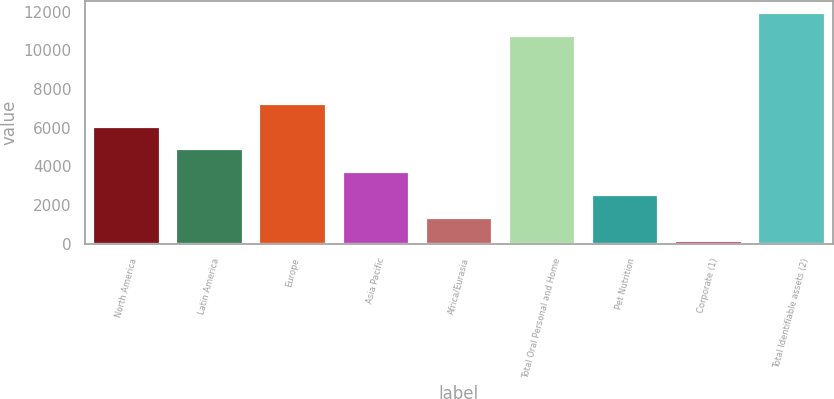Convert chart. <chart><loc_0><loc_0><loc_500><loc_500><bar_chart><fcel>North America<fcel>Latin America<fcel>Europe<fcel>Asia Pacific<fcel>Africa/Eurasia<fcel>Total Oral Personal and Home<fcel>Pet Nutrition<fcel>Corporate (1)<fcel>Total Identifiable assets (2)<nl><fcel>6056.5<fcel>4880.8<fcel>7232.2<fcel>3705.1<fcel>1353.7<fcel>10751<fcel>2529.4<fcel>178<fcel>11935<nl></chart> 